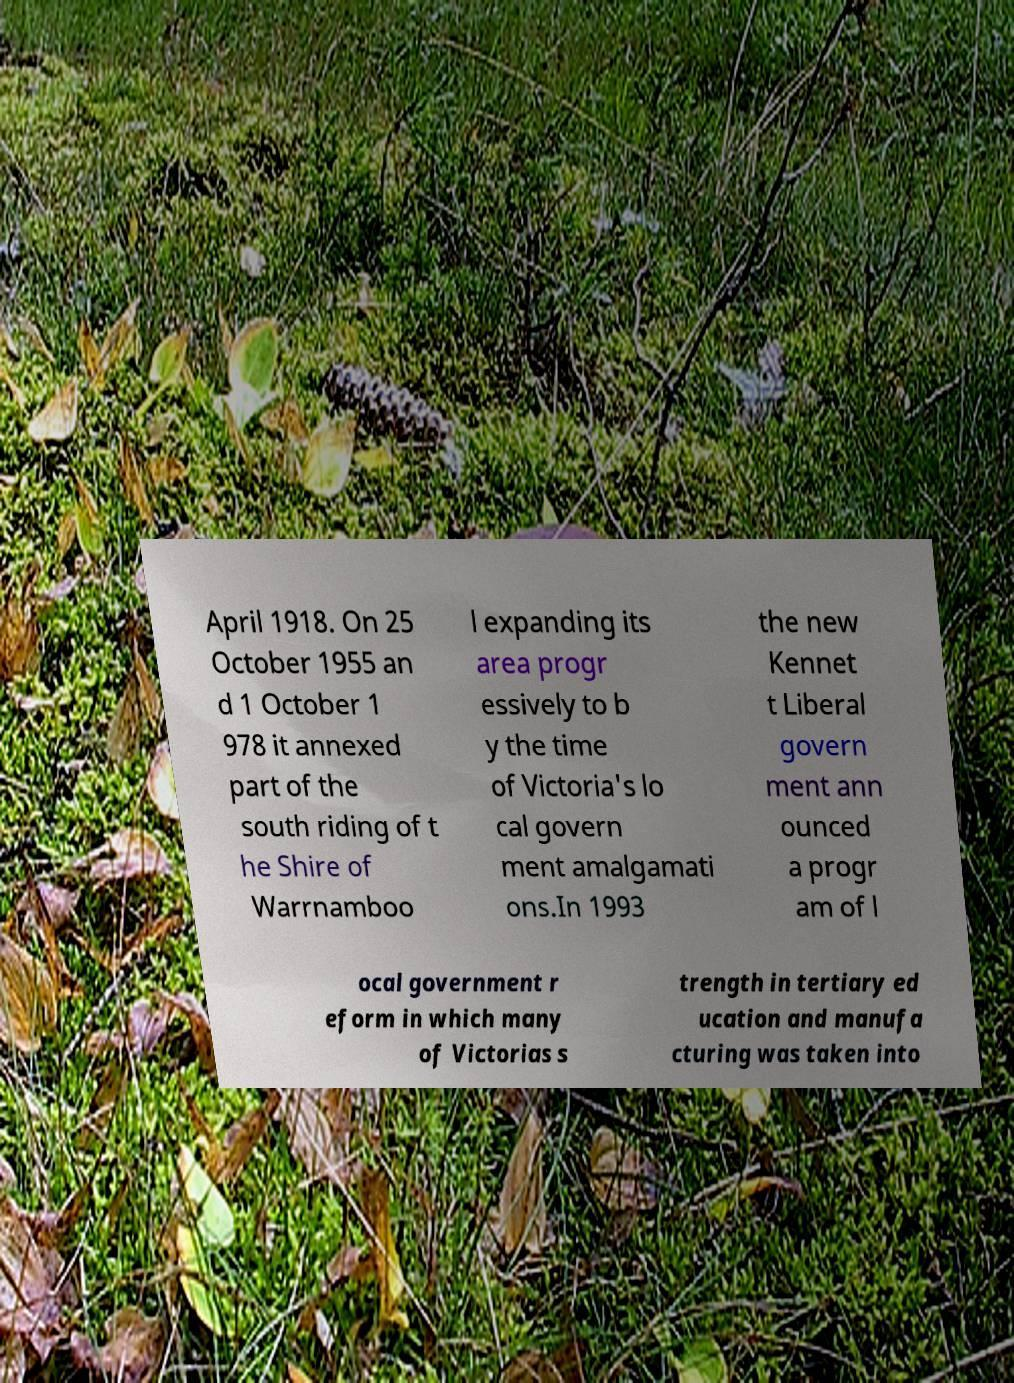Please identify and transcribe the text found in this image. April 1918. On 25 October 1955 an d 1 October 1 978 it annexed part of the south riding of t he Shire of Warrnamboo l expanding its area progr essively to b y the time of Victoria's lo cal govern ment amalgamati ons.In 1993 the new Kennet t Liberal govern ment ann ounced a progr am of l ocal government r eform in which many of Victorias s trength in tertiary ed ucation and manufa cturing was taken into 